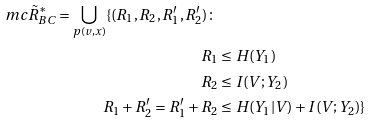Convert formula to latex. <formula><loc_0><loc_0><loc_500><loc_500>\ m c { \tilde { R } } _ { B C } ^ { * } = \bigcup _ { p ( v , x ) } \{ ( R _ { 1 } , R _ { 2 } , R _ { 1 } ^ { \prime } , R _ { 2 } ^ { \prime } ) \colon & \\ R _ { 1 } & \leq H ( Y _ { 1 } ) \\ R _ { 2 } & \leq I ( V ; Y _ { 2 } ) \\ R _ { 1 } + R _ { 2 } ^ { \prime } = R _ { 1 } ^ { \prime } + R _ { 2 } & \leq H ( Y _ { 1 } | V ) + I ( V ; Y _ { 2 } ) \}</formula> 